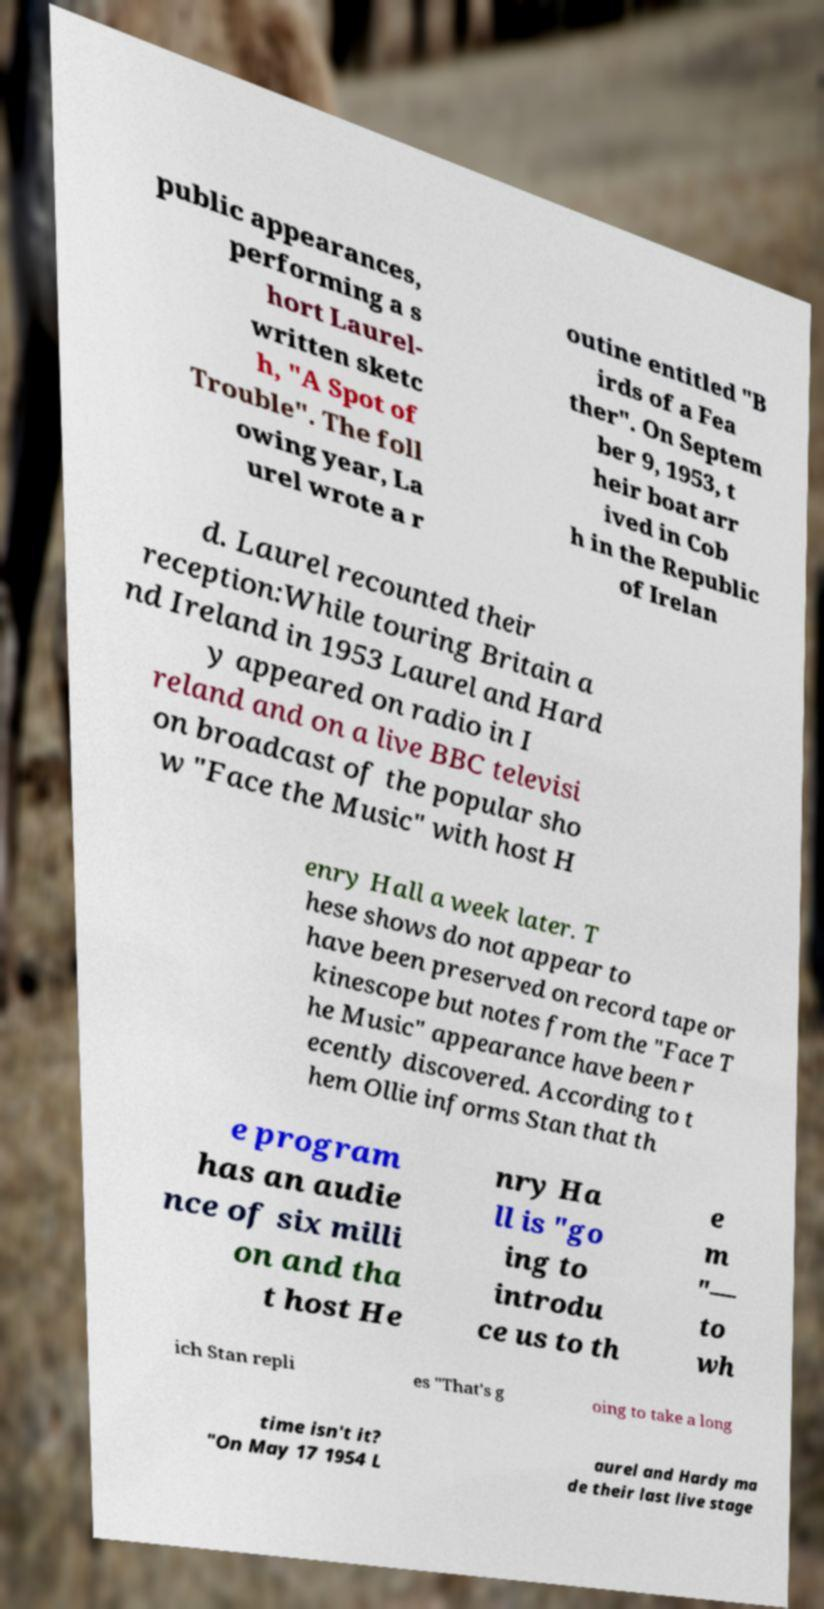Can you accurately transcribe the text from the provided image for me? public appearances, performing a s hort Laurel- written sketc h, "A Spot of Trouble". The foll owing year, La urel wrote a r outine entitled "B irds of a Fea ther". On Septem ber 9, 1953, t heir boat arr ived in Cob h in the Republic of Irelan d. Laurel recounted their reception:While touring Britain a nd Ireland in 1953 Laurel and Hard y appeared on radio in I reland and on a live BBC televisi on broadcast of the popular sho w "Face the Music" with host H enry Hall a week later. T hese shows do not appear to have been preserved on record tape or kinescope but notes from the "Face T he Music" appearance have been r ecently discovered. According to t hem Ollie informs Stan that th e program has an audie nce of six milli on and tha t host He nry Ha ll is "go ing to introdu ce us to th e m "— to wh ich Stan repli es "That's g oing to take a long time isn't it? "On May 17 1954 L aurel and Hardy ma de their last live stage 